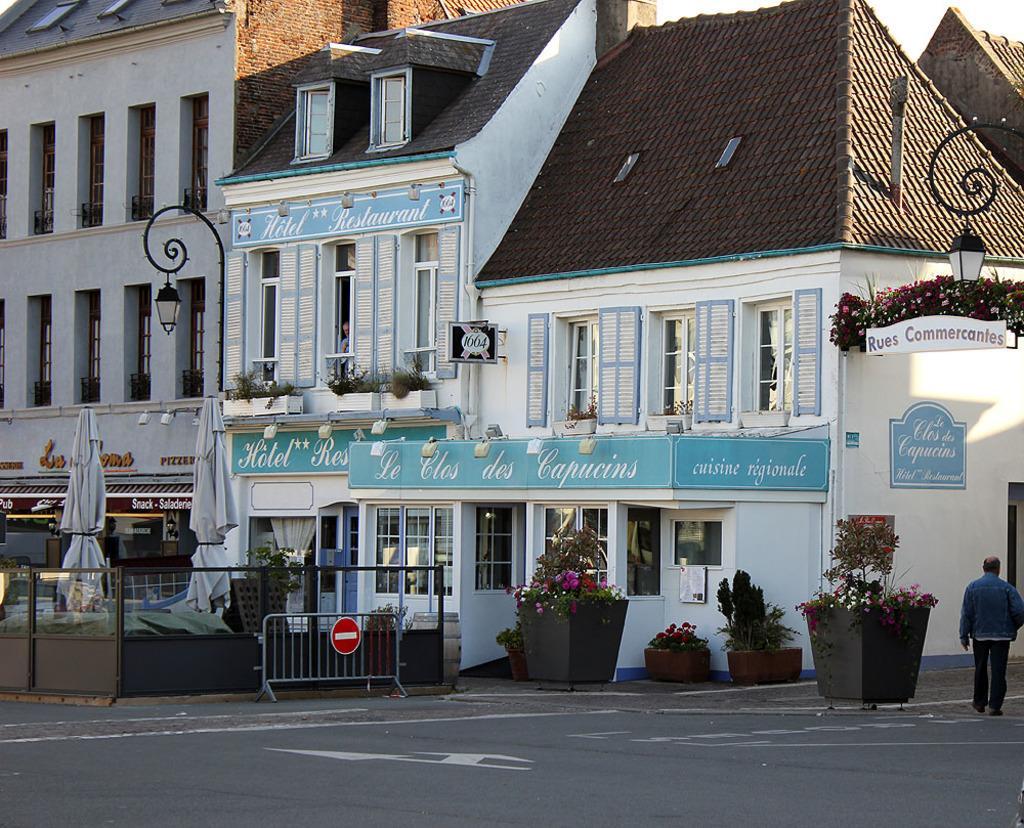In one or two sentences, can you explain what this image depicts? In this picture we can see few buildings, in front of the buildings we can find few lights, hoardings, plants, an umbrellas and metal rods, and also we can see a man is walking on the road. 